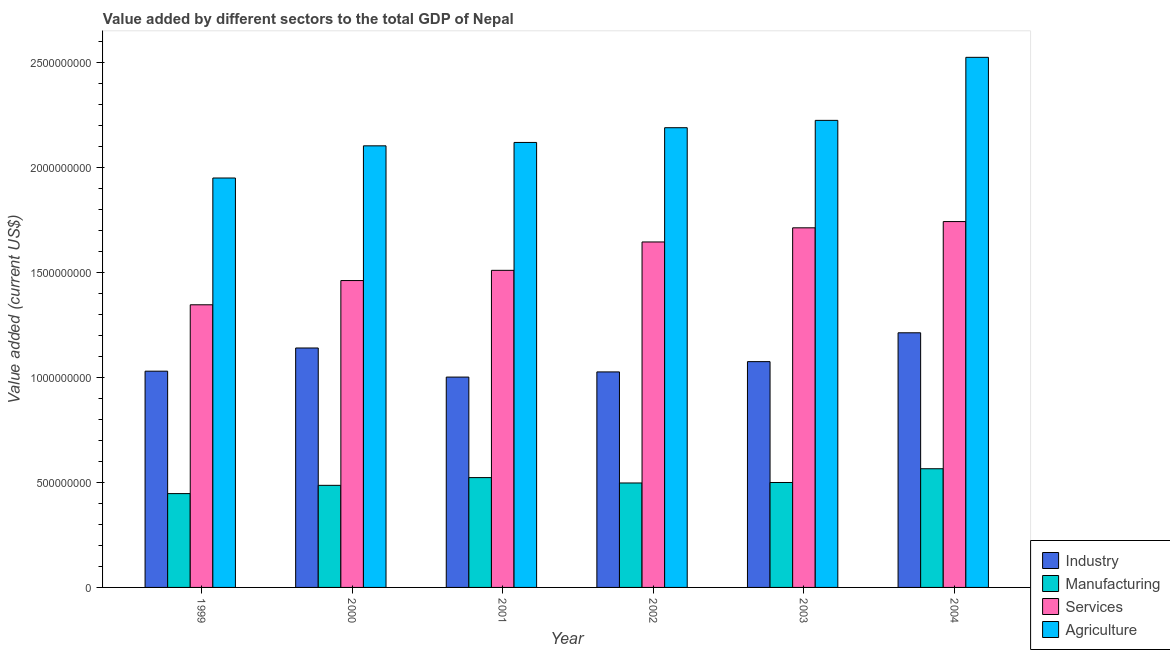How many groups of bars are there?
Make the answer very short. 6. Are the number of bars on each tick of the X-axis equal?
Make the answer very short. Yes. How many bars are there on the 3rd tick from the left?
Your answer should be very brief. 4. In how many cases, is the number of bars for a given year not equal to the number of legend labels?
Your answer should be compact. 0. What is the value added by agricultural sector in 1999?
Provide a succinct answer. 1.95e+09. Across all years, what is the maximum value added by industrial sector?
Make the answer very short. 1.21e+09. Across all years, what is the minimum value added by manufacturing sector?
Make the answer very short. 4.46e+08. In which year was the value added by services sector maximum?
Your answer should be compact. 2004. What is the total value added by services sector in the graph?
Keep it short and to the point. 9.41e+09. What is the difference between the value added by services sector in 2001 and that in 2004?
Your answer should be compact. -2.32e+08. What is the difference between the value added by manufacturing sector in 2004 and the value added by services sector in 1999?
Offer a very short reply. 1.18e+08. What is the average value added by industrial sector per year?
Your response must be concise. 1.08e+09. What is the ratio of the value added by agricultural sector in 2000 to that in 2004?
Give a very brief answer. 0.83. Is the value added by industrial sector in 1999 less than that in 2003?
Your answer should be very brief. Yes. Is the difference between the value added by industrial sector in 2000 and 2001 greater than the difference between the value added by manufacturing sector in 2000 and 2001?
Offer a terse response. No. What is the difference between the highest and the second highest value added by agricultural sector?
Offer a very short reply. 3.00e+08. What is the difference between the highest and the lowest value added by agricultural sector?
Ensure brevity in your answer.  5.74e+08. Is it the case that in every year, the sum of the value added by manufacturing sector and value added by agricultural sector is greater than the sum of value added by services sector and value added by industrial sector?
Your answer should be compact. No. What does the 4th bar from the left in 2002 represents?
Your answer should be compact. Agriculture. What does the 1st bar from the right in 2001 represents?
Your answer should be very brief. Agriculture. Is it the case that in every year, the sum of the value added by industrial sector and value added by manufacturing sector is greater than the value added by services sector?
Offer a very short reply. No. Are all the bars in the graph horizontal?
Ensure brevity in your answer.  No. Are the values on the major ticks of Y-axis written in scientific E-notation?
Provide a succinct answer. No. Where does the legend appear in the graph?
Offer a very short reply. Bottom right. How many legend labels are there?
Ensure brevity in your answer.  4. How are the legend labels stacked?
Keep it short and to the point. Vertical. What is the title of the graph?
Ensure brevity in your answer.  Value added by different sectors to the total GDP of Nepal. Does "Luxembourg" appear as one of the legend labels in the graph?
Give a very brief answer. No. What is the label or title of the Y-axis?
Keep it short and to the point. Value added (current US$). What is the Value added (current US$) in Industry in 1999?
Ensure brevity in your answer.  1.03e+09. What is the Value added (current US$) of Manufacturing in 1999?
Your answer should be compact. 4.46e+08. What is the Value added (current US$) of Services in 1999?
Your response must be concise. 1.34e+09. What is the Value added (current US$) in Agriculture in 1999?
Give a very brief answer. 1.95e+09. What is the Value added (current US$) of Industry in 2000?
Offer a terse response. 1.14e+09. What is the Value added (current US$) in Manufacturing in 2000?
Offer a very short reply. 4.86e+08. What is the Value added (current US$) of Services in 2000?
Your response must be concise. 1.46e+09. What is the Value added (current US$) of Agriculture in 2000?
Keep it short and to the point. 2.10e+09. What is the Value added (current US$) of Industry in 2001?
Provide a succinct answer. 1.00e+09. What is the Value added (current US$) in Manufacturing in 2001?
Your answer should be very brief. 5.23e+08. What is the Value added (current US$) of Services in 2001?
Your answer should be very brief. 1.51e+09. What is the Value added (current US$) of Agriculture in 2001?
Your answer should be compact. 2.12e+09. What is the Value added (current US$) of Industry in 2002?
Give a very brief answer. 1.03e+09. What is the Value added (current US$) in Manufacturing in 2002?
Ensure brevity in your answer.  4.97e+08. What is the Value added (current US$) of Services in 2002?
Your response must be concise. 1.64e+09. What is the Value added (current US$) in Agriculture in 2002?
Offer a very short reply. 2.19e+09. What is the Value added (current US$) in Industry in 2003?
Your response must be concise. 1.07e+09. What is the Value added (current US$) in Manufacturing in 2003?
Offer a terse response. 4.99e+08. What is the Value added (current US$) in Services in 2003?
Your answer should be compact. 1.71e+09. What is the Value added (current US$) of Agriculture in 2003?
Your answer should be very brief. 2.22e+09. What is the Value added (current US$) of Industry in 2004?
Offer a terse response. 1.21e+09. What is the Value added (current US$) in Manufacturing in 2004?
Give a very brief answer. 5.65e+08. What is the Value added (current US$) of Services in 2004?
Give a very brief answer. 1.74e+09. What is the Value added (current US$) in Agriculture in 2004?
Provide a short and direct response. 2.52e+09. Across all years, what is the maximum Value added (current US$) in Industry?
Give a very brief answer. 1.21e+09. Across all years, what is the maximum Value added (current US$) in Manufacturing?
Offer a terse response. 5.65e+08. Across all years, what is the maximum Value added (current US$) of Services?
Offer a terse response. 1.74e+09. Across all years, what is the maximum Value added (current US$) of Agriculture?
Give a very brief answer. 2.52e+09. Across all years, what is the minimum Value added (current US$) of Industry?
Your answer should be compact. 1.00e+09. Across all years, what is the minimum Value added (current US$) of Manufacturing?
Make the answer very short. 4.46e+08. Across all years, what is the minimum Value added (current US$) of Services?
Keep it short and to the point. 1.34e+09. Across all years, what is the minimum Value added (current US$) in Agriculture?
Keep it short and to the point. 1.95e+09. What is the total Value added (current US$) in Industry in the graph?
Provide a succinct answer. 6.48e+09. What is the total Value added (current US$) of Manufacturing in the graph?
Make the answer very short. 3.02e+09. What is the total Value added (current US$) in Services in the graph?
Your response must be concise. 9.41e+09. What is the total Value added (current US$) in Agriculture in the graph?
Keep it short and to the point. 1.31e+1. What is the difference between the Value added (current US$) of Industry in 1999 and that in 2000?
Provide a succinct answer. -1.10e+08. What is the difference between the Value added (current US$) in Manufacturing in 1999 and that in 2000?
Provide a succinct answer. -3.93e+07. What is the difference between the Value added (current US$) in Services in 1999 and that in 2000?
Your response must be concise. -1.15e+08. What is the difference between the Value added (current US$) in Agriculture in 1999 and that in 2000?
Keep it short and to the point. -1.53e+08. What is the difference between the Value added (current US$) of Industry in 1999 and that in 2001?
Offer a terse response. 2.81e+07. What is the difference between the Value added (current US$) in Manufacturing in 1999 and that in 2001?
Offer a terse response. -7.61e+07. What is the difference between the Value added (current US$) in Services in 1999 and that in 2001?
Your response must be concise. -1.64e+08. What is the difference between the Value added (current US$) in Agriculture in 1999 and that in 2001?
Ensure brevity in your answer.  -1.69e+08. What is the difference between the Value added (current US$) in Industry in 1999 and that in 2002?
Ensure brevity in your answer.  3.50e+06. What is the difference between the Value added (current US$) in Manufacturing in 1999 and that in 2002?
Provide a short and direct response. -5.05e+07. What is the difference between the Value added (current US$) of Services in 1999 and that in 2002?
Keep it short and to the point. -2.99e+08. What is the difference between the Value added (current US$) of Agriculture in 1999 and that in 2002?
Make the answer very short. -2.39e+08. What is the difference between the Value added (current US$) of Industry in 1999 and that in 2003?
Offer a terse response. -4.54e+07. What is the difference between the Value added (current US$) of Manufacturing in 1999 and that in 2003?
Offer a terse response. -5.29e+07. What is the difference between the Value added (current US$) of Services in 1999 and that in 2003?
Your response must be concise. -3.66e+08. What is the difference between the Value added (current US$) in Agriculture in 1999 and that in 2003?
Offer a terse response. -2.74e+08. What is the difference between the Value added (current US$) of Industry in 1999 and that in 2004?
Your response must be concise. -1.83e+08. What is the difference between the Value added (current US$) in Manufacturing in 1999 and that in 2004?
Give a very brief answer. -1.18e+08. What is the difference between the Value added (current US$) of Services in 1999 and that in 2004?
Give a very brief answer. -3.96e+08. What is the difference between the Value added (current US$) of Agriculture in 1999 and that in 2004?
Make the answer very short. -5.74e+08. What is the difference between the Value added (current US$) of Industry in 2000 and that in 2001?
Give a very brief answer. 1.38e+08. What is the difference between the Value added (current US$) of Manufacturing in 2000 and that in 2001?
Provide a succinct answer. -3.68e+07. What is the difference between the Value added (current US$) in Services in 2000 and that in 2001?
Your answer should be compact. -4.86e+07. What is the difference between the Value added (current US$) in Agriculture in 2000 and that in 2001?
Offer a terse response. -1.61e+07. What is the difference between the Value added (current US$) of Industry in 2000 and that in 2002?
Give a very brief answer. 1.14e+08. What is the difference between the Value added (current US$) of Manufacturing in 2000 and that in 2002?
Provide a short and direct response. -1.12e+07. What is the difference between the Value added (current US$) in Services in 2000 and that in 2002?
Offer a terse response. -1.84e+08. What is the difference between the Value added (current US$) in Agriculture in 2000 and that in 2002?
Provide a short and direct response. -8.62e+07. What is the difference between the Value added (current US$) of Industry in 2000 and that in 2003?
Keep it short and to the point. 6.49e+07. What is the difference between the Value added (current US$) of Manufacturing in 2000 and that in 2003?
Your response must be concise. -1.36e+07. What is the difference between the Value added (current US$) of Services in 2000 and that in 2003?
Offer a very short reply. -2.51e+08. What is the difference between the Value added (current US$) in Agriculture in 2000 and that in 2003?
Offer a very short reply. -1.21e+08. What is the difference between the Value added (current US$) of Industry in 2000 and that in 2004?
Your answer should be very brief. -7.24e+07. What is the difference between the Value added (current US$) of Manufacturing in 2000 and that in 2004?
Provide a short and direct response. -7.90e+07. What is the difference between the Value added (current US$) in Services in 2000 and that in 2004?
Provide a short and direct response. -2.81e+08. What is the difference between the Value added (current US$) of Agriculture in 2000 and that in 2004?
Provide a succinct answer. -4.21e+08. What is the difference between the Value added (current US$) in Industry in 2001 and that in 2002?
Your answer should be compact. -2.46e+07. What is the difference between the Value added (current US$) in Manufacturing in 2001 and that in 2002?
Your answer should be very brief. 2.56e+07. What is the difference between the Value added (current US$) in Services in 2001 and that in 2002?
Offer a terse response. -1.35e+08. What is the difference between the Value added (current US$) of Agriculture in 2001 and that in 2002?
Give a very brief answer. -7.01e+07. What is the difference between the Value added (current US$) of Industry in 2001 and that in 2003?
Make the answer very short. -7.35e+07. What is the difference between the Value added (current US$) in Manufacturing in 2001 and that in 2003?
Give a very brief answer. 2.32e+07. What is the difference between the Value added (current US$) in Services in 2001 and that in 2003?
Ensure brevity in your answer.  -2.02e+08. What is the difference between the Value added (current US$) of Agriculture in 2001 and that in 2003?
Give a very brief answer. -1.05e+08. What is the difference between the Value added (current US$) in Industry in 2001 and that in 2004?
Your answer should be very brief. -2.11e+08. What is the difference between the Value added (current US$) in Manufacturing in 2001 and that in 2004?
Offer a terse response. -4.22e+07. What is the difference between the Value added (current US$) in Services in 2001 and that in 2004?
Provide a short and direct response. -2.32e+08. What is the difference between the Value added (current US$) in Agriculture in 2001 and that in 2004?
Provide a succinct answer. -4.05e+08. What is the difference between the Value added (current US$) in Industry in 2002 and that in 2003?
Your response must be concise. -4.89e+07. What is the difference between the Value added (current US$) of Manufacturing in 2002 and that in 2003?
Give a very brief answer. -2.35e+06. What is the difference between the Value added (current US$) of Services in 2002 and that in 2003?
Your answer should be very brief. -6.73e+07. What is the difference between the Value added (current US$) of Agriculture in 2002 and that in 2003?
Offer a very short reply. -3.50e+07. What is the difference between the Value added (current US$) in Industry in 2002 and that in 2004?
Offer a very short reply. -1.86e+08. What is the difference between the Value added (current US$) in Manufacturing in 2002 and that in 2004?
Your answer should be very brief. -6.78e+07. What is the difference between the Value added (current US$) of Services in 2002 and that in 2004?
Provide a short and direct response. -9.71e+07. What is the difference between the Value added (current US$) in Agriculture in 2002 and that in 2004?
Give a very brief answer. -3.35e+08. What is the difference between the Value added (current US$) in Industry in 2003 and that in 2004?
Your response must be concise. -1.37e+08. What is the difference between the Value added (current US$) of Manufacturing in 2003 and that in 2004?
Provide a succinct answer. -6.54e+07. What is the difference between the Value added (current US$) in Services in 2003 and that in 2004?
Your response must be concise. -2.98e+07. What is the difference between the Value added (current US$) in Agriculture in 2003 and that in 2004?
Offer a terse response. -3.00e+08. What is the difference between the Value added (current US$) of Industry in 1999 and the Value added (current US$) of Manufacturing in 2000?
Give a very brief answer. 5.43e+08. What is the difference between the Value added (current US$) in Industry in 1999 and the Value added (current US$) in Services in 2000?
Offer a terse response. -4.31e+08. What is the difference between the Value added (current US$) in Industry in 1999 and the Value added (current US$) in Agriculture in 2000?
Provide a succinct answer. -1.07e+09. What is the difference between the Value added (current US$) in Manufacturing in 1999 and the Value added (current US$) in Services in 2000?
Offer a terse response. -1.01e+09. What is the difference between the Value added (current US$) in Manufacturing in 1999 and the Value added (current US$) in Agriculture in 2000?
Your answer should be very brief. -1.65e+09. What is the difference between the Value added (current US$) in Services in 1999 and the Value added (current US$) in Agriculture in 2000?
Keep it short and to the point. -7.56e+08. What is the difference between the Value added (current US$) in Industry in 1999 and the Value added (current US$) in Manufacturing in 2001?
Your answer should be compact. 5.06e+08. What is the difference between the Value added (current US$) in Industry in 1999 and the Value added (current US$) in Services in 2001?
Provide a succinct answer. -4.80e+08. What is the difference between the Value added (current US$) in Industry in 1999 and the Value added (current US$) in Agriculture in 2001?
Make the answer very short. -1.09e+09. What is the difference between the Value added (current US$) of Manufacturing in 1999 and the Value added (current US$) of Services in 2001?
Your response must be concise. -1.06e+09. What is the difference between the Value added (current US$) in Manufacturing in 1999 and the Value added (current US$) in Agriculture in 2001?
Ensure brevity in your answer.  -1.67e+09. What is the difference between the Value added (current US$) in Services in 1999 and the Value added (current US$) in Agriculture in 2001?
Your answer should be compact. -7.72e+08. What is the difference between the Value added (current US$) in Industry in 1999 and the Value added (current US$) in Manufacturing in 2002?
Provide a succinct answer. 5.32e+08. What is the difference between the Value added (current US$) of Industry in 1999 and the Value added (current US$) of Services in 2002?
Keep it short and to the point. -6.15e+08. What is the difference between the Value added (current US$) of Industry in 1999 and the Value added (current US$) of Agriculture in 2002?
Your answer should be very brief. -1.16e+09. What is the difference between the Value added (current US$) in Manufacturing in 1999 and the Value added (current US$) in Services in 2002?
Offer a very short reply. -1.20e+09. What is the difference between the Value added (current US$) in Manufacturing in 1999 and the Value added (current US$) in Agriculture in 2002?
Provide a succinct answer. -1.74e+09. What is the difference between the Value added (current US$) in Services in 1999 and the Value added (current US$) in Agriculture in 2002?
Keep it short and to the point. -8.43e+08. What is the difference between the Value added (current US$) in Industry in 1999 and the Value added (current US$) in Manufacturing in 2003?
Give a very brief answer. 5.30e+08. What is the difference between the Value added (current US$) in Industry in 1999 and the Value added (current US$) in Services in 2003?
Offer a terse response. -6.82e+08. What is the difference between the Value added (current US$) in Industry in 1999 and the Value added (current US$) in Agriculture in 2003?
Your response must be concise. -1.19e+09. What is the difference between the Value added (current US$) in Manufacturing in 1999 and the Value added (current US$) in Services in 2003?
Your answer should be very brief. -1.26e+09. What is the difference between the Value added (current US$) in Manufacturing in 1999 and the Value added (current US$) in Agriculture in 2003?
Your answer should be very brief. -1.78e+09. What is the difference between the Value added (current US$) in Services in 1999 and the Value added (current US$) in Agriculture in 2003?
Your answer should be very brief. -8.77e+08. What is the difference between the Value added (current US$) in Industry in 1999 and the Value added (current US$) in Manufacturing in 2004?
Provide a short and direct response. 4.64e+08. What is the difference between the Value added (current US$) in Industry in 1999 and the Value added (current US$) in Services in 2004?
Offer a terse response. -7.12e+08. What is the difference between the Value added (current US$) of Industry in 1999 and the Value added (current US$) of Agriculture in 2004?
Your answer should be compact. -1.49e+09. What is the difference between the Value added (current US$) of Manufacturing in 1999 and the Value added (current US$) of Services in 2004?
Keep it short and to the point. -1.29e+09. What is the difference between the Value added (current US$) of Manufacturing in 1999 and the Value added (current US$) of Agriculture in 2004?
Offer a very short reply. -2.08e+09. What is the difference between the Value added (current US$) in Services in 1999 and the Value added (current US$) in Agriculture in 2004?
Offer a very short reply. -1.18e+09. What is the difference between the Value added (current US$) of Industry in 2000 and the Value added (current US$) of Manufacturing in 2001?
Your answer should be very brief. 6.17e+08. What is the difference between the Value added (current US$) in Industry in 2000 and the Value added (current US$) in Services in 2001?
Provide a succinct answer. -3.70e+08. What is the difference between the Value added (current US$) of Industry in 2000 and the Value added (current US$) of Agriculture in 2001?
Provide a succinct answer. -9.78e+08. What is the difference between the Value added (current US$) in Manufacturing in 2000 and the Value added (current US$) in Services in 2001?
Offer a terse response. -1.02e+09. What is the difference between the Value added (current US$) in Manufacturing in 2000 and the Value added (current US$) in Agriculture in 2001?
Offer a very short reply. -1.63e+09. What is the difference between the Value added (current US$) of Services in 2000 and the Value added (current US$) of Agriculture in 2001?
Keep it short and to the point. -6.57e+08. What is the difference between the Value added (current US$) of Industry in 2000 and the Value added (current US$) of Manufacturing in 2002?
Keep it short and to the point. 6.42e+08. What is the difference between the Value added (current US$) of Industry in 2000 and the Value added (current US$) of Services in 2002?
Your response must be concise. -5.05e+08. What is the difference between the Value added (current US$) in Industry in 2000 and the Value added (current US$) in Agriculture in 2002?
Provide a short and direct response. -1.05e+09. What is the difference between the Value added (current US$) in Manufacturing in 2000 and the Value added (current US$) in Services in 2002?
Provide a succinct answer. -1.16e+09. What is the difference between the Value added (current US$) of Manufacturing in 2000 and the Value added (current US$) of Agriculture in 2002?
Ensure brevity in your answer.  -1.70e+09. What is the difference between the Value added (current US$) of Services in 2000 and the Value added (current US$) of Agriculture in 2002?
Make the answer very short. -7.27e+08. What is the difference between the Value added (current US$) of Industry in 2000 and the Value added (current US$) of Manufacturing in 2003?
Offer a terse response. 6.40e+08. What is the difference between the Value added (current US$) in Industry in 2000 and the Value added (current US$) in Services in 2003?
Make the answer very short. -5.72e+08. What is the difference between the Value added (current US$) in Industry in 2000 and the Value added (current US$) in Agriculture in 2003?
Give a very brief answer. -1.08e+09. What is the difference between the Value added (current US$) of Manufacturing in 2000 and the Value added (current US$) of Services in 2003?
Offer a very short reply. -1.23e+09. What is the difference between the Value added (current US$) of Manufacturing in 2000 and the Value added (current US$) of Agriculture in 2003?
Provide a short and direct response. -1.74e+09. What is the difference between the Value added (current US$) in Services in 2000 and the Value added (current US$) in Agriculture in 2003?
Give a very brief answer. -7.62e+08. What is the difference between the Value added (current US$) of Industry in 2000 and the Value added (current US$) of Manufacturing in 2004?
Provide a short and direct response. 5.75e+08. What is the difference between the Value added (current US$) of Industry in 2000 and the Value added (current US$) of Services in 2004?
Your answer should be compact. -6.02e+08. What is the difference between the Value added (current US$) in Industry in 2000 and the Value added (current US$) in Agriculture in 2004?
Your response must be concise. -1.38e+09. What is the difference between the Value added (current US$) in Manufacturing in 2000 and the Value added (current US$) in Services in 2004?
Offer a terse response. -1.26e+09. What is the difference between the Value added (current US$) of Manufacturing in 2000 and the Value added (current US$) of Agriculture in 2004?
Offer a terse response. -2.04e+09. What is the difference between the Value added (current US$) of Services in 2000 and the Value added (current US$) of Agriculture in 2004?
Give a very brief answer. -1.06e+09. What is the difference between the Value added (current US$) of Industry in 2001 and the Value added (current US$) of Manufacturing in 2002?
Provide a short and direct response. 5.04e+08. What is the difference between the Value added (current US$) of Industry in 2001 and the Value added (current US$) of Services in 2002?
Provide a succinct answer. -6.43e+08. What is the difference between the Value added (current US$) in Industry in 2001 and the Value added (current US$) in Agriculture in 2002?
Make the answer very short. -1.19e+09. What is the difference between the Value added (current US$) of Manufacturing in 2001 and the Value added (current US$) of Services in 2002?
Ensure brevity in your answer.  -1.12e+09. What is the difference between the Value added (current US$) of Manufacturing in 2001 and the Value added (current US$) of Agriculture in 2002?
Your answer should be compact. -1.66e+09. What is the difference between the Value added (current US$) of Services in 2001 and the Value added (current US$) of Agriculture in 2002?
Provide a short and direct response. -6.79e+08. What is the difference between the Value added (current US$) in Industry in 2001 and the Value added (current US$) in Manufacturing in 2003?
Provide a short and direct response. 5.01e+08. What is the difference between the Value added (current US$) in Industry in 2001 and the Value added (current US$) in Services in 2003?
Provide a succinct answer. -7.10e+08. What is the difference between the Value added (current US$) in Industry in 2001 and the Value added (current US$) in Agriculture in 2003?
Make the answer very short. -1.22e+09. What is the difference between the Value added (current US$) in Manufacturing in 2001 and the Value added (current US$) in Services in 2003?
Make the answer very short. -1.19e+09. What is the difference between the Value added (current US$) in Manufacturing in 2001 and the Value added (current US$) in Agriculture in 2003?
Offer a very short reply. -1.70e+09. What is the difference between the Value added (current US$) in Services in 2001 and the Value added (current US$) in Agriculture in 2003?
Provide a succinct answer. -7.14e+08. What is the difference between the Value added (current US$) in Industry in 2001 and the Value added (current US$) in Manufacturing in 2004?
Your answer should be compact. 4.36e+08. What is the difference between the Value added (current US$) of Industry in 2001 and the Value added (current US$) of Services in 2004?
Keep it short and to the point. -7.40e+08. What is the difference between the Value added (current US$) in Industry in 2001 and the Value added (current US$) in Agriculture in 2004?
Provide a succinct answer. -1.52e+09. What is the difference between the Value added (current US$) in Manufacturing in 2001 and the Value added (current US$) in Services in 2004?
Ensure brevity in your answer.  -1.22e+09. What is the difference between the Value added (current US$) of Manufacturing in 2001 and the Value added (current US$) of Agriculture in 2004?
Your response must be concise. -2.00e+09. What is the difference between the Value added (current US$) of Services in 2001 and the Value added (current US$) of Agriculture in 2004?
Provide a succinct answer. -1.01e+09. What is the difference between the Value added (current US$) in Industry in 2002 and the Value added (current US$) in Manufacturing in 2003?
Offer a very short reply. 5.26e+08. What is the difference between the Value added (current US$) of Industry in 2002 and the Value added (current US$) of Services in 2003?
Keep it short and to the point. -6.86e+08. What is the difference between the Value added (current US$) of Industry in 2002 and the Value added (current US$) of Agriculture in 2003?
Provide a succinct answer. -1.20e+09. What is the difference between the Value added (current US$) in Manufacturing in 2002 and the Value added (current US$) in Services in 2003?
Make the answer very short. -1.21e+09. What is the difference between the Value added (current US$) in Manufacturing in 2002 and the Value added (current US$) in Agriculture in 2003?
Your response must be concise. -1.73e+09. What is the difference between the Value added (current US$) in Services in 2002 and the Value added (current US$) in Agriculture in 2003?
Give a very brief answer. -5.79e+08. What is the difference between the Value added (current US$) of Industry in 2002 and the Value added (current US$) of Manufacturing in 2004?
Make the answer very short. 4.61e+08. What is the difference between the Value added (current US$) of Industry in 2002 and the Value added (current US$) of Services in 2004?
Keep it short and to the point. -7.15e+08. What is the difference between the Value added (current US$) in Industry in 2002 and the Value added (current US$) in Agriculture in 2004?
Ensure brevity in your answer.  -1.50e+09. What is the difference between the Value added (current US$) in Manufacturing in 2002 and the Value added (current US$) in Services in 2004?
Your answer should be very brief. -1.24e+09. What is the difference between the Value added (current US$) of Manufacturing in 2002 and the Value added (current US$) of Agriculture in 2004?
Keep it short and to the point. -2.03e+09. What is the difference between the Value added (current US$) in Services in 2002 and the Value added (current US$) in Agriculture in 2004?
Your response must be concise. -8.79e+08. What is the difference between the Value added (current US$) of Industry in 2003 and the Value added (current US$) of Manufacturing in 2004?
Your answer should be very brief. 5.10e+08. What is the difference between the Value added (current US$) of Industry in 2003 and the Value added (current US$) of Services in 2004?
Make the answer very short. -6.66e+08. What is the difference between the Value added (current US$) in Industry in 2003 and the Value added (current US$) in Agriculture in 2004?
Your response must be concise. -1.45e+09. What is the difference between the Value added (current US$) in Manufacturing in 2003 and the Value added (current US$) in Services in 2004?
Offer a terse response. -1.24e+09. What is the difference between the Value added (current US$) of Manufacturing in 2003 and the Value added (current US$) of Agriculture in 2004?
Your answer should be very brief. -2.02e+09. What is the difference between the Value added (current US$) in Services in 2003 and the Value added (current US$) in Agriculture in 2004?
Make the answer very short. -8.11e+08. What is the average Value added (current US$) of Industry per year?
Make the answer very short. 1.08e+09. What is the average Value added (current US$) of Manufacturing per year?
Provide a succinct answer. 5.03e+08. What is the average Value added (current US$) of Services per year?
Your answer should be very brief. 1.57e+09. What is the average Value added (current US$) of Agriculture per year?
Offer a very short reply. 2.18e+09. In the year 1999, what is the difference between the Value added (current US$) of Industry and Value added (current US$) of Manufacturing?
Provide a succinct answer. 5.82e+08. In the year 1999, what is the difference between the Value added (current US$) in Industry and Value added (current US$) in Services?
Your answer should be very brief. -3.16e+08. In the year 1999, what is the difference between the Value added (current US$) of Industry and Value added (current US$) of Agriculture?
Your answer should be compact. -9.19e+08. In the year 1999, what is the difference between the Value added (current US$) in Manufacturing and Value added (current US$) in Services?
Keep it short and to the point. -8.98e+08. In the year 1999, what is the difference between the Value added (current US$) of Manufacturing and Value added (current US$) of Agriculture?
Keep it short and to the point. -1.50e+09. In the year 1999, what is the difference between the Value added (current US$) in Services and Value added (current US$) in Agriculture?
Offer a very short reply. -6.03e+08. In the year 2000, what is the difference between the Value added (current US$) in Industry and Value added (current US$) in Manufacturing?
Provide a succinct answer. 6.54e+08. In the year 2000, what is the difference between the Value added (current US$) of Industry and Value added (current US$) of Services?
Your response must be concise. -3.21e+08. In the year 2000, what is the difference between the Value added (current US$) of Industry and Value added (current US$) of Agriculture?
Your answer should be compact. -9.62e+08. In the year 2000, what is the difference between the Value added (current US$) of Manufacturing and Value added (current US$) of Services?
Your answer should be very brief. -9.74e+08. In the year 2000, what is the difference between the Value added (current US$) in Manufacturing and Value added (current US$) in Agriculture?
Offer a very short reply. -1.62e+09. In the year 2000, what is the difference between the Value added (current US$) in Services and Value added (current US$) in Agriculture?
Offer a very short reply. -6.41e+08. In the year 2001, what is the difference between the Value added (current US$) of Industry and Value added (current US$) of Manufacturing?
Ensure brevity in your answer.  4.78e+08. In the year 2001, what is the difference between the Value added (current US$) in Industry and Value added (current US$) in Services?
Provide a short and direct response. -5.08e+08. In the year 2001, what is the difference between the Value added (current US$) in Industry and Value added (current US$) in Agriculture?
Offer a terse response. -1.12e+09. In the year 2001, what is the difference between the Value added (current US$) of Manufacturing and Value added (current US$) of Services?
Ensure brevity in your answer.  -9.86e+08. In the year 2001, what is the difference between the Value added (current US$) in Manufacturing and Value added (current US$) in Agriculture?
Keep it short and to the point. -1.59e+09. In the year 2001, what is the difference between the Value added (current US$) in Services and Value added (current US$) in Agriculture?
Make the answer very short. -6.09e+08. In the year 2002, what is the difference between the Value added (current US$) of Industry and Value added (current US$) of Manufacturing?
Give a very brief answer. 5.28e+08. In the year 2002, what is the difference between the Value added (current US$) of Industry and Value added (current US$) of Services?
Ensure brevity in your answer.  -6.18e+08. In the year 2002, what is the difference between the Value added (current US$) of Industry and Value added (current US$) of Agriculture?
Your answer should be very brief. -1.16e+09. In the year 2002, what is the difference between the Value added (current US$) in Manufacturing and Value added (current US$) in Services?
Offer a terse response. -1.15e+09. In the year 2002, what is the difference between the Value added (current US$) in Manufacturing and Value added (current US$) in Agriculture?
Provide a succinct answer. -1.69e+09. In the year 2002, what is the difference between the Value added (current US$) of Services and Value added (current US$) of Agriculture?
Keep it short and to the point. -5.44e+08. In the year 2003, what is the difference between the Value added (current US$) in Industry and Value added (current US$) in Manufacturing?
Your response must be concise. 5.75e+08. In the year 2003, what is the difference between the Value added (current US$) of Industry and Value added (current US$) of Services?
Your answer should be compact. -6.37e+08. In the year 2003, what is the difference between the Value added (current US$) of Industry and Value added (current US$) of Agriculture?
Offer a very short reply. -1.15e+09. In the year 2003, what is the difference between the Value added (current US$) in Manufacturing and Value added (current US$) in Services?
Keep it short and to the point. -1.21e+09. In the year 2003, what is the difference between the Value added (current US$) in Manufacturing and Value added (current US$) in Agriculture?
Provide a short and direct response. -1.72e+09. In the year 2003, what is the difference between the Value added (current US$) of Services and Value added (current US$) of Agriculture?
Ensure brevity in your answer.  -5.11e+08. In the year 2004, what is the difference between the Value added (current US$) in Industry and Value added (current US$) in Manufacturing?
Provide a short and direct response. 6.47e+08. In the year 2004, what is the difference between the Value added (current US$) of Industry and Value added (current US$) of Services?
Your answer should be compact. -5.29e+08. In the year 2004, what is the difference between the Value added (current US$) of Industry and Value added (current US$) of Agriculture?
Provide a succinct answer. -1.31e+09. In the year 2004, what is the difference between the Value added (current US$) in Manufacturing and Value added (current US$) in Services?
Ensure brevity in your answer.  -1.18e+09. In the year 2004, what is the difference between the Value added (current US$) in Manufacturing and Value added (current US$) in Agriculture?
Your response must be concise. -1.96e+09. In the year 2004, what is the difference between the Value added (current US$) of Services and Value added (current US$) of Agriculture?
Your answer should be compact. -7.81e+08. What is the ratio of the Value added (current US$) of Industry in 1999 to that in 2000?
Your answer should be compact. 0.9. What is the ratio of the Value added (current US$) in Manufacturing in 1999 to that in 2000?
Provide a short and direct response. 0.92. What is the ratio of the Value added (current US$) in Services in 1999 to that in 2000?
Your response must be concise. 0.92. What is the ratio of the Value added (current US$) of Agriculture in 1999 to that in 2000?
Your answer should be compact. 0.93. What is the ratio of the Value added (current US$) in Industry in 1999 to that in 2001?
Make the answer very short. 1.03. What is the ratio of the Value added (current US$) in Manufacturing in 1999 to that in 2001?
Your answer should be compact. 0.85. What is the ratio of the Value added (current US$) of Services in 1999 to that in 2001?
Make the answer very short. 0.89. What is the ratio of the Value added (current US$) in Agriculture in 1999 to that in 2001?
Offer a terse response. 0.92. What is the ratio of the Value added (current US$) of Industry in 1999 to that in 2002?
Provide a succinct answer. 1. What is the ratio of the Value added (current US$) in Manufacturing in 1999 to that in 2002?
Your answer should be very brief. 0.9. What is the ratio of the Value added (current US$) of Services in 1999 to that in 2002?
Ensure brevity in your answer.  0.82. What is the ratio of the Value added (current US$) of Agriculture in 1999 to that in 2002?
Your answer should be very brief. 0.89. What is the ratio of the Value added (current US$) in Industry in 1999 to that in 2003?
Provide a short and direct response. 0.96. What is the ratio of the Value added (current US$) in Manufacturing in 1999 to that in 2003?
Keep it short and to the point. 0.89. What is the ratio of the Value added (current US$) of Services in 1999 to that in 2003?
Your answer should be compact. 0.79. What is the ratio of the Value added (current US$) of Agriculture in 1999 to that in 2003?
Your answer should be compact. 0.88. What is the ratio of the Value added (current US$) in Industry in 1999 to that in 2004?
Ensure brevity in your answer.  0.85. What is the ratio of the Value added (current US$) in Manufacturing in 1999 to that in 2004?
Offer a very short reply. 0.79. What is the ratio of the Value added (current US$) of Services in 1999 to that in 2004?
Your answer should be compact. 0.77. What is the ratio of the Value added (current US$) in Agriculture in 1999 to that in 2004?
Give a very brief answer. 0.77. What is the ratio of the Value added (current US$) in Industry in 2000 to that in 2001?
Keep it short and to the point. 1.14. What is the ratio of the Value added (current US$) in Manufacturing in 2000 to that in 2001?
Provide a short and direct response. 0.93. What is the ratio of the Value added (current US$) in Services in 2000 to that in 2001?
Your answer should be very brief. 0.97. What is the ratio of the Value added (current US$) in Industry in 2000 to that in 2002?
Ensure brevity in your answer.  1.11. What is the ratio of the Value added (current US$) of Manufacturing in 2000 to that in 2002?
Provide a short and direct response. 0.98. What is the ratio of the Value added (current US$) of Services in 2000 to that in 2002?
Give a very brief answer. 0.89. What is the ratio of the Value added (current US$) of Agriculture in 2000 to that in 2002?
Your answer should be very brief. 0.96. What is the ratio of the Value added (current US$) of Industry in 2000 to that in 2003?
Make the answer very short. 1.06. What is the ratio of the Value added (current US$) of Manufacturing in 2000 to that in 2003?
Offer a very short reply. 0.97. What is the ratio of the Value added (current US$) of Services in 2000 to that in 2003?
Provide a short and direct response. 0.85. What is the ratio of the Value added (current US$) of Agriculture in 2000 to that in 2003?
Your answer should be compact. 0.95. What is the ratio of the Value added (current US$) of Industry in 2000 to that in 2004?
Provide a short and direct response. 0.94. What is the ratio of the Value added (current US$) of Manufacturing in 2000 to that in 2004?
Make the answer very short. 0.86. What is the ratio of the Value added (current US$) of Services in 2000 to that in 2004?
Give a very brief answer. 0.84. What is the ratio of the Value added (current US$) in Agriculture in 2000 to that in 2004?
Ensure brevity in your answer.  0.83. What is the ratio of the Value added (current US$) of Manufacturing in 2001 to that in 2002?
Give a very brief answer. 1.05. What is the ratio of the Value added (current US$) in Services in 2001 to that in 2002?
Your answer should be very brief. 0.92. What is the ratio of the Value added (current US$) in Agriculture in 2001 to that in 2002?
Provide a short and direct response. 0.97. What is the ratio of the Value added (current US$) of Industry in 2001 to that in 2003?
Keep it short and to the point. 0.93. What is the ratio of the Value added (current US$) of Manufacturing in 2001 to that in 2003?
Offer a very short reply. 1.05. What is the ratio of the Value added (current US$) of Services in 2001 to that in 2003?
Your answer should be compact. 0.88. What is the ratio of the Value added (current US$) in Agriculture in 2001 to that in 2003?
Provide a short and direct response. 0.95. What is the ratio of the Value added (current US$) of Industry in 2001 to that in 2004?
Your response must be concise. 0.83. What is the ratio of the Value added (current US$) of Manufacturing in 2001 to that in 2004?
Offer a very short reply. 0.93. What is the ratio of the Value added (current US$) in Services in 2001 to that in 2004?
Your answer should be very brief. 0.87. What is the ratio of the Value added (current US$) in Agriculture in 2001 to that in 2004?
Provide a short and direct response. 0.84. What is the ratio of the Value added (current US$) in Industry in 2002 to that in 2003?
Offer a terse response. 0.95. What is the ratio of the Value added (current US$) of Services in 2002 to that in 2003?
Offer a terse response. 0.96. What is the ratio of the Value added (current US$) in Agriculture in 2002 to that in 2003?
Offer a very short reply. 0.98. What is the ratio of the Value added (current US$) of Industry in 2002 to that in 2004?
Provide a short and direct response. 0.85. What is the ratio of the Value added (current US$) of Manufacturing in 2002 to that in 2004?
Give a very brief answer. 0.88. What is the ratio of the Value added (current US$) of Services in 2002 to that in 2004?
Your response must be concise. 0.94. What is the ratio of the Value added (current US$) in Agriculture in 2002 to that in 2004?
Your answer should be very brief. 0.87. What is the ratio of the Value added (current US$) of Industry in 2003 to that in 2004?
Your answer should be compact. 0.89. What is the ratio of the Value added (current US$) of Manufacturing in 2003 to that in 2004?
Your answer should be very brief. 0.88. What is the ratio of the Value added (current US$) in Services in 2003 to that in 2004?
Provide a succinct answer. 0.98. What is the ratio of the Value added (current US$) of Agriculture in 2003 to that in 2004?
Make the answer very short. 0.88. What is the difference between the highest and the second highest Value added (current US$) in Industry?
Provide a succinct answer. 7.24e+07. What is the difference between the highest and the second highest Value added (current US$) in Manufacturing?
Make the answer very short. 4.22e+07. What is the difference between the highest and the second highest Value added (current US$) in Services?
Provide a succinct answer. 2.98e+07. What is the difference between the highest and the second highest Value added (current US$) of Agriculture?
Keep it short and to the point. 3.00e+08. What is the difference between the highest and the lowest Value added (current US$) in Industry?
Keep it short and to the point. 2.11e+08. What is the difference between the highest and the lowest Value added (current US$) in Manufacturing?
Ensure brevity in your answer.  1.18e+08. What is the difference between the highest and the lowest Value added (current US$) of Services?
Your answer should be compact. 3.96e+08. What is the difference between the highest and the lowest Value added (current US$) of Agriculture?
Make the answer very short. 5.74e+08. 